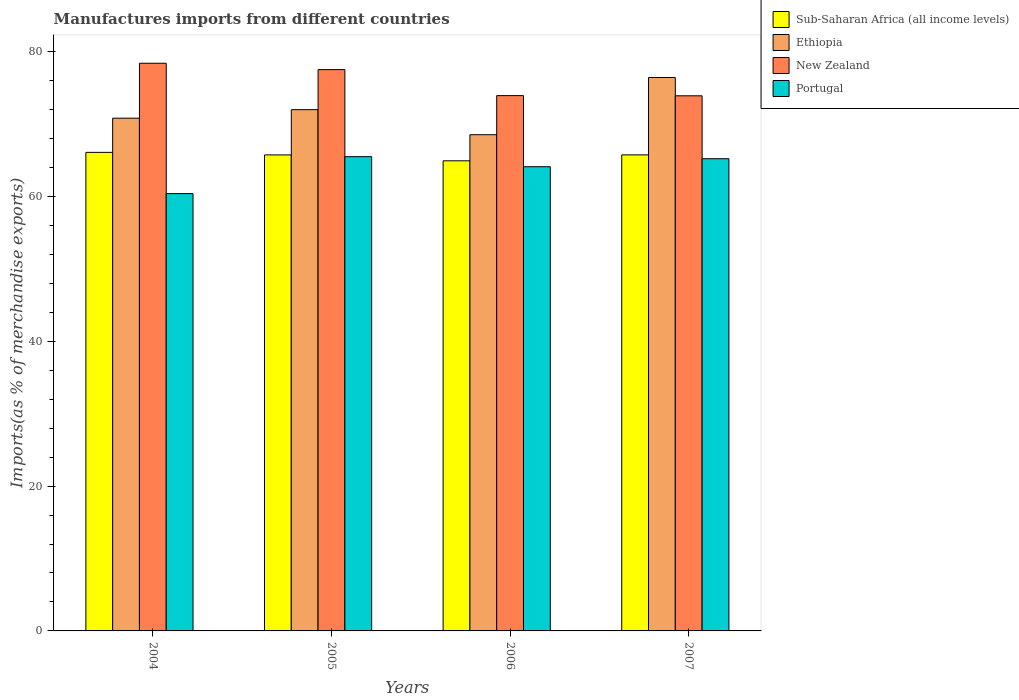How many different coloured bars are there?
Give a very brief answer. 4. Are the number of bars on each tick of the X-axis equal?
Offer a very short reply. Yes. How many bars are there on the 1st tick from the left?
Offer a very short reply. 4. What is the percentage of imports to different countries in New Zealand in 2004?
Ensure brevity in your answer.  78.38. Across all years, what is the maximum percentage of imports to different countries in Sub-Saharan Africa (all income levels)?
Your answer should be very brief. 66.08. Across all years, what is the minimum percentage of imports to different countries in Sub-Saharan Africa (all income levels)?
Keep it short and to the point. 64.91. What is the total percentage of imports to different countries in Ethiopia in the graph?
Your answer should be very brief. 287.7. What is the difference between the percentage of imports to different countries in Ethiopia in 2004 and that in 2007?
Offer a terse response. -5.62. What is the difference between the percentage of imports to different countries in Ethiopia in 2007 and the percentage of imports to different countries in Portugal in 2005?
Your answer should be very brief. 10.93. What is the average percentage of imports to different countries in New Zealand per year?
Provide a succinct answer. 75.92. In the year 2005, what is the difference between the percentage of imports to different countries in New Zealand and percentage of imports to different countries in Ethiopia?
Give a very brief answer. 5.53. What is the ratio of the percentage of imports to different countries in Sub-Saharan Africa (all income levels) in 2004 to that in 2007?
Offer a very short reply. 1.01. Is the percentage of imports to different countries in New Zealand in 2005 less than that in 2006?
Offer a terse response. No. What is the difference between the highest and the second highest percentage of imports to different countries in Portugal?
Keep it short and to the point. 0.28. What is the difference between the highest and the lowest percentage of imports to different countries in Ethiopia?
Offer a very short reply. 7.9. Is the sum of the percentage of imports to different countries in Sub-Saharan Africa (all income levels) in 2004 and 2007 greater than the maximum percentage of imports to different countries in Ethiopia across all years?
Give a very brief answer. Yes. Is it the case that in every year, the sum of the percentage of imports to different countries in New Zealand and percentage of imports to different countries in Portugal is greater than the sum of percentage of imports to different countries in Ethiopia and percentage of imports to different countries in Sub-Saharan Africa (all income levels)?
Your answer should be very brief. No. What does the 2nd bar from the left in 2006 represents?
Your response must be concise. Ethiopia. What does the 2nd bar from the right in 2004 represents?
Provide a succinct answer. New Zealand. Is it the case that in every year, the sum of the percentage of imports to different countries in Portugal and percentage of imports to different countries in Ethiopia is greater than the percentage of imports to different countries in New Zealand?
Make the answer very short. Yes. How many bars are there?
Ensure brevity in your answer.  16. How many years are there in the graph?
Your response must be concise. 4. What is the difference between two consecutive major ticks on the Y-axis?
Ensure brevity in your answer.  20. Are the values on the major ticks of Y-axis written in scientific E-notation?
Make the answer very short. No. How many legend labels are there?
Provide a short and direct response. 4. What is the title of the graph?
Keep it short and to the point. Manufactures imports from different countries. Does "Latin America(all income levels)" appear as one of the legend labels in the graph?
Offer a terse response. No. What is the label or title of the X-axis?
Give a very brief answer. Years. What is the label or title of the Y-axis?
Provide a short and direct response. Imports(as % of merchandise exports). What is the Imports(as % of merchandise exports) in Sub-Saharan Africa (all income levels) in 2004?
Your answer should be compact. 66.08. What is the Imports(as % of merchandise exports) of Ethiopia in 2004?
Offer a very short reply. 70.8. What is the Imports(as % of merchandise exports) in New Zealand in 2004?
Ensure brevity in your answer.  78.38. What is the Imports(as % of merchandise exports) of Portugal in 2004?
Ensure brevity in your answer.  60.38. What is the Imports(as % of merchandise exports) of Sub-Saharan Africa (all income levels) in 2005?
Keep it short and to the point. 65.72. What is the Imports(as % of merchandise exports) in Ethiopia in 2005?
Your response must be concise. 71.97. What is the Imports(as % of merchandise exports) of New Zealand in 2005?
Your response must be concise. 77.5. What is the Imports(as % of merchandise exports) of Portugal in 2005?
Keep it short and to the point. 65.48. What is the Imports(as % of merchandise exports) in Sub-Saharan Africa (all income levels) in 2006?
Provide a succinct answer. 64.91. What is the Imports(as % of merchandise exports) of Ethiopia in 2006?
Offer a terse response. 68.51. What is the Imports(as % of merchandise exports) in New Zealand in 2006?
Give a very brief answer. 73.91. What is the Imports(as % of merchandise exports) of Portugal in 2006?
Offer a very short reply. 64.09. What is the Imports(as % of merchandise exports) of Sub-Saharan Africa (all income levels) in 2007?
Give a very brief answer. 65.73. What is the Imports(as % of merchandise exports) of Ethiopia in 2007?
Keep it short and to the point. 76.41. What is the Imports(as % of merchandise exports) of New Zealand in 2007?
Make the answer very short. 73.89. What is the Imports(as % of merchandise exports) of Portugal in 2007?
Offer a terse response. 65.2. Across all years, what is the maximum Imports(as % of merchandise exports) in Sub-Saharan Africa (all income levels)?
Your answer should be very brief. 66.08. Across all years, what is the maximum Imports(as % of merchandise exports) of Ethiopia?
Your response must be concise. 76.41. Across all years, what is the maximum Imports(as % of merchandise exports) of New Zealand?
Your answer should be very brief. 78.38. Across all years, what is the maximum Imports(as % of merchandise exports) of Portugal?
Your answer should be very brief. 65.48. Across all years, what is the minimum Imports(as % of merchandise exports) of Sub-Saharan Africa (all income levels)?
Offer a very short reply. 64.91. Across all years, what is the minimum Imports(as % of merchandise exports) in Ethiopia?
Ensure brevity in your answer.  68.51. Across all years, what is the minimum Imports(as % of merchandise exports) in New Zealand?
Provide a succinct answer. 73.89. Across all years, what is the minimum Imports(as % of merchandise exports) in Portugal?
Provide a short and direct response. 60.38. What is the total Imports(as % of merchandise exports) of Sub-Saharan Africa (all income levels) in the graph?
Your answer should be compact. 262.44. What is the total Imports(as % of merchandise exports) of Ethiopia in the graph?
Offer a very short reply. 287.7. What is the total Imports(as % of merchandise exports) of New Zealand in the graph?
Provide a succinct answer. 303.68. What is the total Imports(as % of merchandise exports) of Portugal in the graph?
Keep it short and to the point. 255.15. What is the difference between the Imports(as % of merchandise exports) of Sub-Saharan Africa (all income levels) in 2004 and that in 2005?
Your answer should be very brief. 0.35. What is the difference between the Imports(as % of merchandise exports) in Ethiopia in 2004 and that in 2005?
Ensure brevity in your answer.  -1.18. What is the difference between the Imports(as % of merchandise exports) in New Zealand in 2004 and that in 2005?
Offer a terse response. 0.88. What is the difference between the Imports(as % of merchandise exports) of Portugal in 2004 and that in 2005?
Your answer should be very brief. -5.1. What is the difference between the Imports(as % of merchandise exports) in Sub-Saharan Africa (all income levels) in 2004 and that in 2006?
Your answer should be very brief. 1.16. What is the difference between the Imports(as % of merchandise exports) of Ethiopia in 2004 and that in 2006?
Offer a very short reply. 2.28. What is the difference between the Imports(as % of merchandise exports) in New Zealand in 2004 and that in 2006?
Make the answer very short. 4.47. What is the difference between the Imports(as % of merchandise exports) of Portugal in 2004 and that in 2006?
Make the answer very short. -3.71. What is the difference between the Imports(as % of merchandise exports) of Sub-Saharan Africa (all income levels) in 2004 and that in 2007?
Keep it short and to the point. 0.35. What is the difference between the Imports(as % of merchandise exports) in Ethiopia in 2004 and that in 2007?
Provide a succinct answer. -5.62. What is the difference between the Imports(as % of merchandise exports) in New Zealand in 2004 and that in 2007?
Ensure brevity in your answer.  4.49. What is the difference between the Imports(as % of merchandise exports) of Portugal in 2004 and that in 2007?
Provide a short and direct response. -4.81. What is the difference between the Imports(as % of merchandise exports) in Sub-Saharan Africa (all income levels) in 2005 and that in 2006?
Offer a very short reply. 0.81. What is the difference between the Imports(as % of merchandise exports) in Ethiopia in 2005 and that in 2006?
Your answer should be very brief. 3.46. What is the difference between the Imports(as % of merchandise exports) of New Zealand in 2005 and that in 2006?
Your answer should be compact. 3.59. What is the difference between the Imports(as % of merchandise exports) in Portugal in 2005 and that in 2006?
Make the answer very short. 1.39. What is the difference between the Imports(as % of merchandise exports) of Sub-Saharan Africa (all income levels) in 2005 and that in 2007?
Your response must be concise. -0. What is the difference between the Imports(as % of merchandise exports) of Ethiopia in 2005 and that in 2007?
Keep it short and to the point. -4.44. What is the difference between the Imports(as % of merchandise exports) in New Zealand in 2005 and that in 2007?
Make the answer very short. 3.62. What is the difference between the Imports(as % of merchandise exports) of Portugal in 2005 and that in 2007?
Provide a short and direct response. 0.28. What is the difference between the Imports(as % of merchandise exports) of Sub-Saharan Africa (all income levels) in 2006 and that in 2007?
Your response must be concise. -0.82. What is the difference between the Imports(as % of merchandise exports) of Ethiopia in 2006 and that in 2007?
Provide a succinct answer. -7.9. What is the difference between the Imports(as % of merchandise exports) in New Zealand in 2006 and that in 2007?
Ensure brevity in your answer.  0.03. What is the difference between the Imports(as % of merchandise exports) of Portugal in 2006 and that in 2007?
Your answer should be compact. -1.1. What is the difference between the Imports(as % of merchandise exports) in Sub-Saharan Africa (all income levels) in 2004 and the Imports(as % of merchandise exports) in Ethiopia in 2005?
Keep it short and to the point. -5.9. What is the difference between the Imports(as % of merchandise exports) in Sub-Saharan Africa (all income levels) in 2004 and the Imports(as % of merchandise exports) in New Zealand in 2005?
Offer a terse response. -11.43. What is the difference between the Imports(as % of merchandise exports) of Sub-Saharan Africa (all income levels) in 2004 and the Imports(as % of merchandise exports) of Portugal in 2005?
Your answer should be very brief. 0.6. What is the difference between the Imports(as % of merchandise exports) of Ethiopia in 2004 and the Imports(as % of merchandise exports) of New Zealand in 2005?
Your response must be concise. -6.7. What is the difference between the Imports(as % of merchandise exports) of Ethiopia in 2004 and the Imports(as % of merchandise exports) of Portugal in 2005?
Keep it short and to the point. 5.32. What is the difference between the Imports(as % of merchandise exports) of New Zealand in 2004 and the Imports(as % of merchandise exports) of Portugal in 2005?
Ensure brevity in your answer.  12.9. What is the difference between the Imports(as % of merchandise exports) in Sub-Saharan Africa (all income levels) in 2004 and the Imports(as % of merchandise exports) in Ethiopia in 2006?
Offer a terse response. -2.44. What is the difference between the Imports(as % of merchandise exports) in Sub-Saharan Africa (all income levels) in 2004 and the Imports(as % of merchandise exports) in New Zealand in 2006?
Offer a terse response. -7.84. What is the difference between the Imports(as % of merchandise exports) of Sub-Saharan Africa (all income levels) in 2004 and the Imports(as % of merchandise exports) of Portugal in 2006?
Offer a terse response. 1.98. What is the difference between the Imports(as % of merchandise exports) of Ethiopia in 2004 and the Imports(as % of merchandise exports) of New Zealand in 2006?
Ensure brevity in your answer.  -3.11. What is the difference between the Imports(as % of merchandise exports) of Ethiopia in 2004 and the Imports(as % of merchandise exports) of Portugal in 2006?
Make the answer very short. 6.7. What is the difference between the Imports(as % of merchandise exports) of New Zealand in 2004 and the Imports(as % of merchandise exports) of Portugal in 2006?
Offer a terse response. 14.29. What is the difference between the Imports(as % of merchandise exports) of Sub-Saharan Africa (all income levels) in 2004 and the Imports(as % of merchandise exports) of Ethiopia in 2007?
Give a very brief answer. -10.34. What is the difference between the Imports(as % of merchandise exports) of Sub-Saharan Africa (all income levels) in 2004 and the Imports(as % of merchandise exports) of New Zealand in 2007?
Make the answer very short. -7.81. What is the difference between the Imports(as % of merchandise exports) in Sub-Saharan Africa (all income levels) in 2004 and the Imports(as % of merchandise exports) in Portugal in 2007?
Offer a very short reply. 0.88. What is the difference between the Imports(as % of merchandise exports) of Ethiopia in 2004 and the Imports(as % of merchandise exports) of New Zealand in 2007?
Keep it short and to the point. -3.09. What is the difference between the Imports(as % of merchandise exports) in Ethiopia in 2004 and the Imports(as % of merchandise exports) in Portugal in 2007?
Give a very brief answer. 5.6. What is the difference between the Imports(as % of merchandise exports) in New Zealand in 2004 and the Imports(as % of merchandise exports) in Portugal in 2007?
Provide a short and direct response. 13.18. What is the difference between the Imports(as % of merchandise exports) of Sub-Saharan Africa (all income levels) in 2005 and the Imports(as % of merchandise exports) of Ethiopia in 2006?
Offer a terse response. -2.79. What is the difference between the Imports(as % of merchandise exports) in Sub-Saharan Africa (all income levels) in 2005 and the Imports(as % of merchandise exports) in New Zealand in 2006?
Your answer should be compact. -8.19. What is the difference between the Imports(as % of merchandise exports) in Sub-Saharan Africa (all income levels) in 2005 and the Imports(as % of merchandise exports) in Portugal in 2006?
Keep it short and to the point. 1.63. What is the difference between the Imports(as % of merchandise exports) of Ethiopia in 2005 and the Imports(as % of merchandise exports) of New Zealand in 2006?
Offer a terse response. -1.94. What is the difference between the Imports(as % of merchandise exports) of Ethiopia in 2005 and the Imports(as % of merchandise exports) of Portugal in 2006?
Ensure brevity in your answer.  7.88. What is the difference between the Imports(as % of merchandise exports) in New Zealand in 2005 and the Imports(as % of merchandise exports) in Portugal in 2006?
Provide a short and direct response. 13.41. What is the difference between the Imports(as % of merchandise exports) of Sub-Saharan Africa (all income levels) in 2005 and the Imports(as % of merchandise exports) of Ethiopia in 2007?
Offer a very short reply. -10.69. What is the difference between the Imports(as % of merchandise exports) of Sub-Saharan Africa (all income levels) in 2005 and the Imports(as % of merchandise exports) of New Zealand in 2007?
Offer a very short reply. -8.16. What is the difference between the Imports(as % of merchandise exports) in Sub-Saharan Africa (all income levels) in 2005 and the Imports(as % of merchandise exports) in Portugal in 2007?
Offer a terse response. 0.53. What is the difference between the Imports(as % of merchandise exports) of Ethiopia in 2005 and the Imports(as % of merchandise exports) of New Zealand in 2007?
Provide a short and direct response. -1.91. What is the difference between the Imports(as % of merchandise exports) of Ethiopia in 2005 and the Imports(as % of merchandise exports) of Portugal in 2007?
Provide a short and direct response. 6.78. What is the difference between the Imports(as % of merchandise exports) of New Zealand in 2005 and the Imports(as % of merchandise exports) of Portugal in 2007?
Your response must be concise. 12.3. What is the difference between the Imports(as % of merchandise exports) in Sub-Saharan Africa (all income levels) in 2006 and the Imports(as % of merchandise exports) in Ethiopia in 2007?
Provide a succinct answer. -11.5. What is the difference between the Imports(as % of merchandise exports) in Sub-Saharan Africa (all income levels) in 2006 and the Imports(as % of merchandise exports) in New Zealand in 2007?
Offer a terse response. -8.98. What is the difference between the Imports(as % of merchandise exports) of Sub-Saharan Africa (all income levels) in 2006 and the Imports(as % of merchandise exports) of Portugal in 2007?
Your response must be concise. -0.29. What is the difference between the Imports(as % of merchandise exports) of Ethiopia in 2006 and the Imports(as % of merchandise exports) of New Zealand in 2007?
Your answer should be compact. -5.37. What is the difference between the Imports(as % of merchandise exports) of Ethiopia in 2006 and the Imports(as % of merchandise exports) of Portugal in 2007?
Your response must be concise. 3.32. What is the difference between the Imports(as % of merchandise exports) in New Zealand in 2006 and the Imports(as % of merchandise exports) in Portugal in 2007?
Your response must be concise. 8.71. What is the average Imports(as % of merchandise exports) of Sub-Saharan Africa (all income levels) per year?
Make the answer very short. 65.61. What is the average Imports(as % of merchandise exports) of Ethiopia per year?
Make the answer very short. 71.92. What is the average Imports(as % of merchandise exports) in New Zealand per year?
Offer a very short reply. 75.92. What is the average Imports(as % of merchandise exports) in Portugal per year?
Offer a very short reply. 63.79. In the year 2004, what is the difference between the Imports(as % of merchandise exports) of Sub-Saharan Africa (all income levels) and Imports(as % of merchandise exports) of Ethiopia?
Your answer should be very brief. -4.72. In the year 2004, what is the difference between the Imports(as % of merchandise exports) of Sub-Saharan Africa (all income levels) and Imports(as % of merchandise exports) of New Zealand?
Ensure brevity in your answer.  -12.3. In the year 2004, what is the difference between the Imports(as % of merchandise exports) of Sub-Saharan Africa (all income levels) and Imports(as % of merchandise exports) of Portugal?
Provide a short and direct response. 5.69. In the year 2004, what is the difference between the Imports(as % of merchandise exports) of Ethiopia and Imports(as % of merchandise exports) of New Zealand?
Provide a succinct answer. -7.58. In the year 2004, what is the difference between the Imports(as % of merchandise exports) of Ethiopia and Imports(as % of merchandise exports) of Portugal?
Offer a terse response. 10.41. In the year 2004, what is the difference between the Imports(as % of merchandise exports) in New Zealand and Imports(as % of merchandise exports) in Portugal?
Your answer should be compact. 18. In the year 2005, what is the difference between the Imports(as % of merchandise exports) of Sub-Saharan Africa (all income levels) and Imports(as % of merchandise exports) of Ethiopia?
Provide a short and direct response. -6.25. In the year 2005, what is the difference between the Imports(as % of merchandise exports) in Sub-Saharan Africa (all income levels) and Imports(as % of merchandise exports) in New Zealand?
Your answer should be very brief. -11.78. In the year 2005, what is the difference between the Imports(as % of merchandise exports) of Sub-Saharan Africa (all income levels) and Imports(as % of merchandise exports) of Portugal?
Provide a short and direct response. 0.24. In the year 2005, what is the difference between the Imports(as % of merchandise exports) of Ethiopia and Imports(as % of merchandise exports) of New Zealand?
Your answer should be very brief. -5.53. In the year 2005, what is the difference between the Imports(as % of merchandise exports) of Ethiopia and Imports(as % of merchandise exports) of Portugal?
Your answer should be compact. 6.49. In the year 2005, what is the difference between the Imports(as % of merchandise exports) in New Zealand and Imports(as % of merchandise exports) in Portugal?
Provide a short and direct response. 12.02. In the year 2006, what is the difference between the Imports(as % of merchandise exports) of Sub-Saharan Africa (all income levels) and Imports(as % of merchandise exports) of Ethiopia?
Offer a very short reply. -3.6. In the year 2006, what is the difference between the Imports(as % of merchandise exports) of Sub-Saharan Africa (all income levels) and Imports(as % of merchandise exports) of New Zealand?
Keep it short and to the point. -9. In the year 2006, what is the difference between the Imports(as % of merchandise exports) of Sub-Saharan Africa (all income levels) and Imports(as % of merchandise exports) of Portugal?
Your response must be concise. 0.82. In the year 2006, what is the difference between the Imports(as % of merchandise exports) of Ethiopia and Imports(as % of merchandise exports) of New Zealand?
Offer a terse response. -5.4. In the year 2006, what is the difference between the Imports(as % of merchandise exports) of Ethiopia and Imports(as % of merchandise exports) of Portugal?
Offer a very short reply. 4.42. In the year 2006, what is the difference between the Imports(as % of merchandise exports) in New Zealand and Imports(as % of merchandise exports) in Portugal?
Make the answer very short. 9.82. In the year 2007, what is the difference between the Imports(as % of merchandise exports) of Sub-Saharan Africa (all income levels) and Imports(as % of merchandise exports) of Ethiopia?
Make the answer very short. -10.69. In the year 2007, what is the difference between the Imports(as % of merchandise exports) of Sub-Saharan Africa (all income levels) and Imports(as % of merchandise exports) of New Zealand?
Your answer should be very brief. -8.16. In the year 2007, what is the difference between the Imports(as % of merchandise exports) in Sub-Saharan Africa (all income levels) and Imports(as % of merchandise exports) in Portugal?
Your response must be concise. 0.53. In the year 2007, what is the difference between the Imports(as % of merchandise exports) of Ethiopia and Imports(as % of merchandise exports) of New Zealand?
Ensure brevity in your answer.  2.53. In the year 2007, what is the difference between the Imports(as % of merchandise exports) in Ethiopia and Imports(as % of merchandise exports) in Portugal?
Keep it short and to the point. 11.22. In the year 2007, what is the difference between the Imports(as % of merchandise exports) in New Zealand and Imports(as % of merchandise exports) in Portugal?
Your response must be concise. 8.69. What is the ratio of the Imports(as % of merchandise exports) in Sub-Saharan Africa (all income levels) in 2004 to that in 2005?
Provide a succinct answer. 1.01. What is the ratio of the Imports(as % of merchandise exports) in Ethiopia in 2004 to that in 2005?
Give a very brief answer. 0.98. What is the ratio of the Imports(as % of merchandise exports) in New Zealand in 2004 to that in 2005?
Ensure brevity in your answer.  1.01. What is the ratio of the Imports(as % of merchandise exports) of Portugal in 2004 to that in 2005?
Offer a terse response. 0.92. What is the ratio of the Imports(as % of merchandise exports) of Sub-Saharan Africa (all income levels) in 2004 to that in 2006?
Ensure brevity in your answer.  1.02. What is the ratio of the Imports(as % of merchandise exports) in Ethiopia in 2004 to that in 2006?
Provide a succinct answer. 1.03. What is the ratio of the Imports(as % of merchandise exports) of New Zealand in 2004 to that in 2006?
Keep it short and to the point. 1.06. What is the ratio of the Imports(as % of merchandise exports) in Portugal in 2004 to that in 2006?
Ensure brevity in your answer.  0.94. What is the ratio of the Imports(as % of merchandise exports) in Sub-Saharan Africa (all income levels) in 2004 to that in 2007?
Ensure brevity in your answer.  1.01. What is the ratio of the Imports(as % of merchandise exports) in Ethiopia in 2004 to that in 2007?
Your answer should be compact. 0.93. What is the ratio of the Imports(as % of merchandise exports) of New Zealand in 2004 to that in 2007?
Your response must be concise. 1.06. What is the ratio of the Imports(as % of merchandise exports) of Portugal in 2004 to that in 2007?
Provide a short and direct response. 0.93. What is the ratio of the Imports(as % of merchandise exports) in Sub-Saharan Africa (all income levels) in 2005 to that in 2006?
Offer a very short reply. 1.01. What is the ratio of the Imports(as % of merchandise exports) in Ethiopia in 2005 to that in 2006?
Your answer should be compact. 1.05. What is the ratio of the Imports(as % of merchandise exports) in New Zealand in 2005 to that in 2006?
Provide a succinct answer. 1.05. What is the ratio of the Imports(as % of merchandise exports) of Portugal in 2005 to that in 2006?
Offer a very short reply. 1.02. What is the ratio of the Imports(as % of merchandise exports) of Sub-Saharan Africa (all income levels) in 2005 to that in 2007?
Make the answer very short. 1. What is the ratio of the Imports(as % of merchandise exports) of Ethiopia in 2005 to that in 2007?
Keep it short and to the point. 0.94. What is the ratio of the Imports(as % of merchandise exports) of New Zealand in 2005 to that in 2007?
Give a very brief answer. 1.05. What is the ratio of the Imports(as % of merchandise exports) in Portugal in 2005 to that in 2007?
Offer a very short reply. 1. What is the ratio of the Imports(as % of merchandise exports) in Sub-Saharan Africa (all income levels) in 2006 to that in 2007?
Ensure brevity in your answer.  0.99. What is the ratio of the Imports(as % of merchandise exports) of Ethiopia in 2006 to that in 2007?
Ensure brevity in your answer.  0.9. What is the ratio of the Imports(as % of merchandise exports) in New Zealand in 2006 to that in 2007?
Offer a terse response. 1. What is the ratio of the Imports(as % of merchandise exports) of Portugal in 2006 to that in 2007?
Offer a very short reply. 0.98. What is the difference between the highest and the second highest Imports(as % of merchandise exports) in Sub-Saharan Africa (all income levels)?
Keep it short and to the point. 0.35. What is the difference between the highest and the second highest Imports(as % of merchandise exports) in Ethiopia?
Ensure brevity in your answer.  4.44. What is the difference between the highest and the second highest Imports(as % of merchandise exports) in New Zealand?
Make the answer very short. 0.88. What is the difference between the highest and the second highest Imports(as % of merchandise exports) in Portugal?
Keep it short and to the point. 0.28. What is the difference between the highest and the lowest Imports(as % of merchandise exports) of Sub-Saharan Africa (all income levels)?
Offer a terse response. 1.16. What is the difference between the highest and the lowest Imports(as % of merchandise exports) of Ethiopia?
Make the answer very short. 7.9. What is the difference between the highest and the lowest Imports(as % of merchandise exports) of New Zealand?
Make the answer very short. 4.49. What is the difference between the highest and the lowest Imports(as % of merchandise exports) in Portugal?
Ensure brevity in your answer.  5.1. 